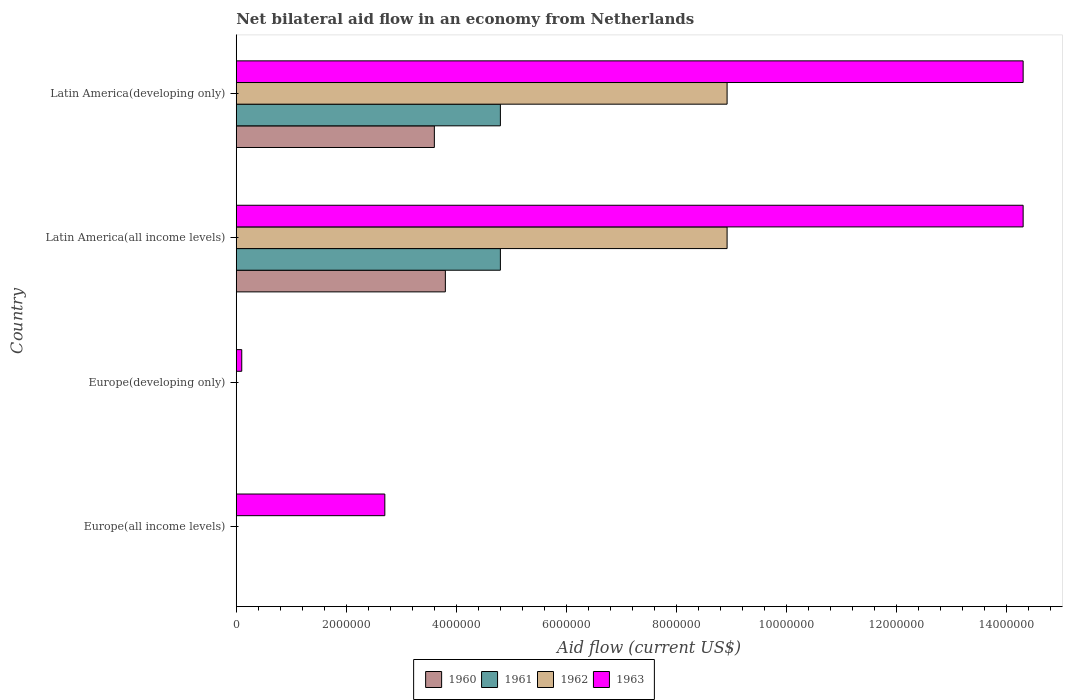How many different coloured bars are there?
Ensure brevity in your answer.  4. What is the label of the 2nd group of bars from the top?
Offer a very short reply. Latin America(all income levels). What is the net bilateral aid flow in 1963 in Europe(all income levels)?
Offer a terse response. 2.70e+06. Across all countries, what is the maximum net bilateral aid flow in 1962?
Offer a very short reply. 8.92e+06. Across all countries, what is the minimum net bilateral aid flow in 1962?
Offer a terse response. 0. In which country was the net bilateral aid flow in 1962 maximum?
Provide a succinct answer. Latin America(all income levels). What is the total net bilateral aid flow in 1963 in the graph?
Your response must be concise. 3.14e+07. What is the difference between the net bilateral aid flow in 1963 in Europe(developing only) and that in Latin America(all income levels)?
Ensure brevity in your answer.  -1.42e+07. What is the difference between the net bilateral aid flow in 1963 in Latin America(developing only) and the net bilateral aid flow in 1962 in Europe(developing only)?
Give a very brief answer. 1.43e+07. What is the average net bilateral aid flow in 1962 per country?
Offer a very short reply. 4.46e+06. What is the difference between the net bilateral aid flow in 1962 and net bilateral aid flow in 1963 in Latin America(all income levels)?
Keep it short and to the point. -5.38e+06. In how many countries, is the net bilateral aid flow in 1963 greater than 2000000 US$?
Offer a terse response. 3. What is the ratio of the net bilateral aid flow in 1962 in Latin America(all income levels) to that in Latin America(developing only)?
Keep it short and to the point. 1. Is the net bilateral aid flow in 1963 in Europe(all income levels) less than that in Latin America(developing only)?
Give a very brief answer. Yes. What is the difference between the highest and the lowest net bilateral aid flow in 1963?
Provide a short and direct response. 1.42e+07. In how many countries, is the net bilateral aid flow in 1962 greater than the average net bilateral aid flow in 1962 taken over all countries?
Make the answer very short. 2. Is it the case that in every country, the sum of the net bilateral aid flow in 1963 and net bilateral aid flow in 1961 is greater than the sum of net bilateral aid flow in 1960 and net bilateral aid flow in 1962?
Ensure brevity in your answer.  No. How many bars are there?
Your response must be concise. 10. What is the difference between two consecutive major ticks on the X-axis?
Offer a terse response. 2.00e+06. Does the graph contain any zero values?
Offer a terse response. Yes. Does the graph contain grids?
Your answer should be compact. No. What is the title of the graph?
Provide a succinct answer. Net bilateral aid flow in an economy from Netherlands. What is the label or title of the X-axis?
Your answer should be very brief. Aid flow (current US$). What is the Aid flow (current US$) of 1962 in Europe(all income levels)?
Give a very brief answer. 0. What is the Aid flow (current US$) of 1963 in Europe(all income levels)?
Provide a short and direct response. 2.70e+06. What is the Aid flow (current US$) in 1960 in Latin America(all income levels)?
Your answer should be very brief. 3.80e+06. What is the Aid flow (current US$) of 1961 in Latin America(all income levels)?
Offer a terse response. 4.80e+06. What is the Aid flow (current US$) of 1962 in Latin America(all income levels)?
Offer a very short reply. 8.92e+06. What is the Aid flow (current US$) of 1963 in Latin America(all income levels)?
Keep it short and to the point. 1.43e+07. What is the Aid flow (current US$) in 1960 in Latin America(developing only)?
Make the answer very short. 3.60e+06. What is the Aid flow (current US$) of 1961 in Latin America(developing only)?
Your response must be concise. 4.80e+06. What is the Aid flow (current US$) in 1962 in Latin America(developing only)?
Ensure brevity in your answer.  8.92e+06. What is the Aid flow (current US$) in 1963 in Latin America(developing only)?
Your answer should be very brief. 1.43e+07. Across all countries, what is the maximum Aid flow (current US$) of 1960?
Give a very brief answer. 3.80e+06. Across all countries, what is the maximum Aid flow (current US$) of 1961?
Keep it short and to the point. 4.80e+06. Across all countries, what is the maximum Aid flow (current US$) of 1962?
Provide a short and direct response. 8.92e+06. Across all countries, what is the maximum Aid flow (current US$) in 1963?
Your response must be concise. 1.43e+07. Across all countries, what is the minimum Aid flow (current US$) in 1962?
Make the answer very short. 0. Across all countries, what is the minimum Aid flow (current US$) of 1963?
Make the answer very short. 1.00e+05. What is the total Aid flow (current US$) in 1960 in the graph?
Ensure brevity in your answer.  7.40e+06. What is the total Aid flow (current US$) of 1961 in the graph?
Give a very brief answer. 9.60e+06. What is the total Aid flow (current US$) in 1962 in the graph?
Offer a terse response. 1.78e+07. What is the total Aid flow (current US$) of 1963 in the graph?
Make the answer very short. 3.14e+07. What is the difference between the Aid flow (current US$) in 1963 in Europe(all income levels) and that in Europe(developing only)?
Keep it short and to the point. 2.60e+06. What is the difference between the Aid flow (current US$) in 1963 in Europe(all income levels) and that in Latin America(all income levels)?
Provide a short and direct response. -1.16e+07. What is the difference between the Aid flow (current US$) in 1963 in Europe(all income levels) and that in Latin America(developing only)?
Your answer should be compact. -1.16e+07. What is the difference between the Aid flow (current US$) in 1963 in Europe(developing only) and that in Latin America(all income levels)?
Make the answer very short. -1.42e+07. What is the difference between the Aid flow (current US$) in 1963 in Europe(developing only) and that in Latin America(developing only)?
Offer a terse response. -1.42e+07. What is the difference between the Aid flow (current US$) of 1960 in Latin America(all income levels) and that in Latin America(developing only)?
Your answer should be very brief. 2.00e+05. What is the difference between the Aid flow (current US$) of 1963 in Latin America(all income levels) and that in Latin America(developing only)?
Your answer should be very brief. 0. What is the difference between the Aid flow (current US$) in 1960 in Latin America(all income levels) and the Aid flow (current US$) in 1961 in Latin America(developing only)?
Offer a terse response. -1.00e+06. What is the difference between the Aid flow (current US$) of 1960 in Latin America(all income levels) and the Aid flow (current US$) of 1962 in Latin America(developing only)?
Your response must be concise. -5.12e+06. What is the difference between the Aid flow (current US$) in 1960 in Latin America(all income levels) and the Aid flow (current US$) in 1963 in Latin America(developing only)?
Offer a terse response. -1.05e+07. What is the difference between the Aid flow (current US$) in 1961 in Latin America(all income levels) and the Aid flow (current US$) in 1962 in Latin America(developing only)?
Keep it short and to the point. -4.12e+06. What is the difference between the Aid flow (current US$) in 1961 in Latin America(all income levels) and the Aid flow (current US$) in 1963 in Latin America(developing only)?
Give a very brief answer. -9.50e+06. What is the difference between the Aid flow (current US$) of 1962 in Latin America(all income levels) and the Aid flow (current US$) of 1963 in Latin America(developing only)?
Offer a terse response. -5.38e+06. What is the average Aid flow (current US$) of 1960 per country?
Provide a succinct answer. 1.85e+06. What is the average Aid flow (current US$) in 1961 per country?
Your response must be concise. 2.40e+06. What is the average Aid flow (current US$) of 1962 per country?
Ensure brevity in your answer.  4.46e+06. What is the average Aid flow (current US$) of 1963 per country?
Your answer should be very brief. 7.85e+06. What is the difference between the Aid flow (current US$) of 1960 and Aid flow (current US$) of 1962 in Latin America(all income levels)?
Your answer should be very brief. -5.12e+06. What is the difference between the Aid flow (current US$) in 1960 and Aid flow (current US$) in 1963 in Latin America(all income levels)?
Provide a short and direct response. -1.05e+07. What is the difference between the Aid flow (current US$) in 1961 and Aid flow (current US$) in 1962 in Latin America(all income levels)?
Your answer should be compact. -4.12e+06. What is the difference between the Aid flow (current US$) in 1961 and Aid flow (current US$) in 1963 in Latin America(all income levels)?
Your response must be concise. -9.50e+06. What is the difference between the Aid flow (current US$) of 1962 and Aid flow (current US$) of 1963 in Latin America(all income levels)?
Ensure brevity in your answer.  -5.38e+06. What is the difference between the Aid flow (current US$) of 1960 and Aid flow (current US$) of 1961 in Latin America(developing only)?
Your answer should be very brief. -1.20e+06. What is the difference between the Aid flow (current US$) of 1960 and Aid flow (current US$) of 1962 in Latin America(developing only)?
Ensure brevity in your answer.  -5.32e+06. What is the difference between the Aid flow (current US$) in 1960 and Aid flow (current US$) in 1963 in Latin America(developing only)?
Provide a short and direct response. -1.07e+07. What is the difference between the Aid flow (current US$) of 1961 and Aid flow (current US$) of 1962 in Latin America(developing only)?
Your answer should be very brief. -4.12e+06. What is the difference between the Aid flow (current US$) of 1961 and Aid flow (current US$) of 1963 in Latin America(developing only)?
Your answer should be very brief. -9.50e+06. What is the difference between the Aid flow (current US$) of 1962 and Aid flow (current US$) of 1963 in Latin America(developing only)?
Provide a short and direct response. -5.38e+06. What is the ratio of the Aid flow (current US$) in 1963 in Europe(all income levels) to that in Latin America(all income levels)?
Your answer should be very brief. 0.19. What is the ratio of the Aid flow (current US$) in 1963 in Europe(all income levels) to that in Latin America(developing only)?
Provide a succinct answer. 0.19. What is the ratio of the Aid flow (current US$) in 1963 in Europe(developing only) to that in Latin America(all income levels)?
Provide a succinct answer. 0.01. What is the ratio of the Aid flow (current US$) of 1963 in Europe(developing only) to that in Latin America(developing only)?
Make the answer very short. 0.01. What is the ratio of the Aid flow (current US$) in 1960 in Latin America(all income levels) to that in Latin America(developing only)?
Your answer should be very brief. 1.06. What is the ratio of the Aid flow (current US$) in 1963 in Latin America(all income levels) to that in Latin America(developing only)?
Ensure brevity in your answer.  1. What is the difference between the highest and the lowest Aid flow (current US$) in 1960?
Offer a very short reply. 3.80e+06. What is the difference between the highest and the lowest Aid flow (current US$) of 1961?
Provide a succinct answer. 4.80e+06. What is the difference between the highest and the lowest Aid flow (current US$) in 1962?
Keep it short and to the point. 8.92e+06. What is the difference between the highest and the lowest Aid flow (current US$) of 1963?
Your answer should be compact. 1.42e+07. 